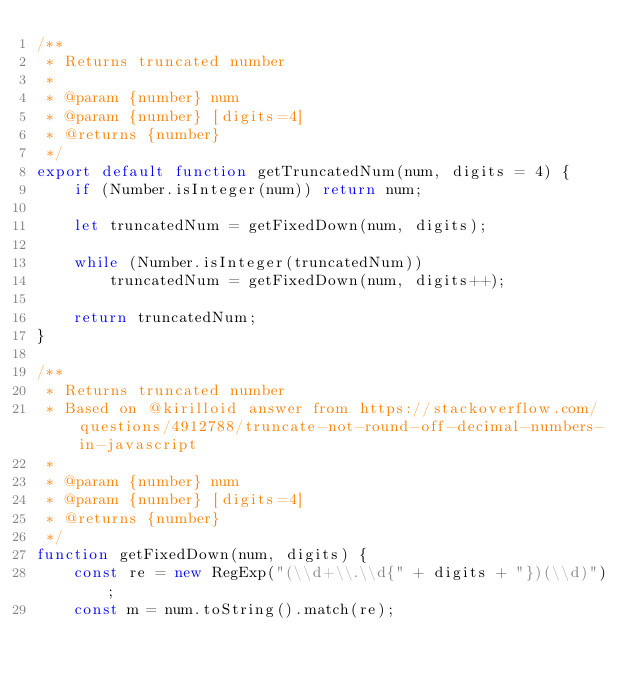<code> <loc_0><loc_0><loc_500><loc_500><_JavaScript_>/**
 * Returns truncated number
 * 
 * @param {number} num
 * @param {number} [digits=4]
 * @returns {number}
 */
export default function getTruncatedNum(num, digits = 4) {
	if (Number.isInteger(num)) return num;

	let truncatedNum = getFixedDown(num, digits);

	while (Number.isInteger(truncatedNum))
		truncatedNum = getFixedDown(num, digits++);
	
	return truncatedNum;
}

/**
 * Returns truncated number
 * Based on @kirilloid answer from https://stackoverflow.com/questions/4912788/truncate-not-round-off-decimal-numbers-in-javascript 
 * 
 * @param {number} num
 * @param {number} [digits=4]
 * @returns {number}
 */
function getFixedDown(num, digits) {
	const re = new RegExp("(\\d+\\.\\d{" + digits + "})(\\d)");
    const m = num.toString().match(re);</code> 